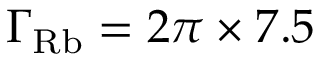Convert formula to latex. <formula><loc_0><loc_0><loc_500><loc_500>\Gamma _ { R b } = 2 \pi \times 7 . 5</formula> 